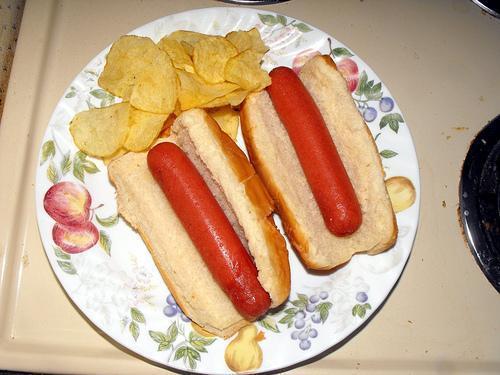How many hotdogs are in this picture?
Give a very brief answer. 2. 